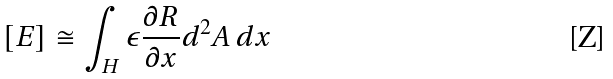Convert formula to latex. <formula><loc_0><loc_0><loc_500><loc_500>[ E ] \cong \int _ { H } \epsilon \frac { \partial R } { \partial x } d ^ { 2 } A \, d x</formula> 